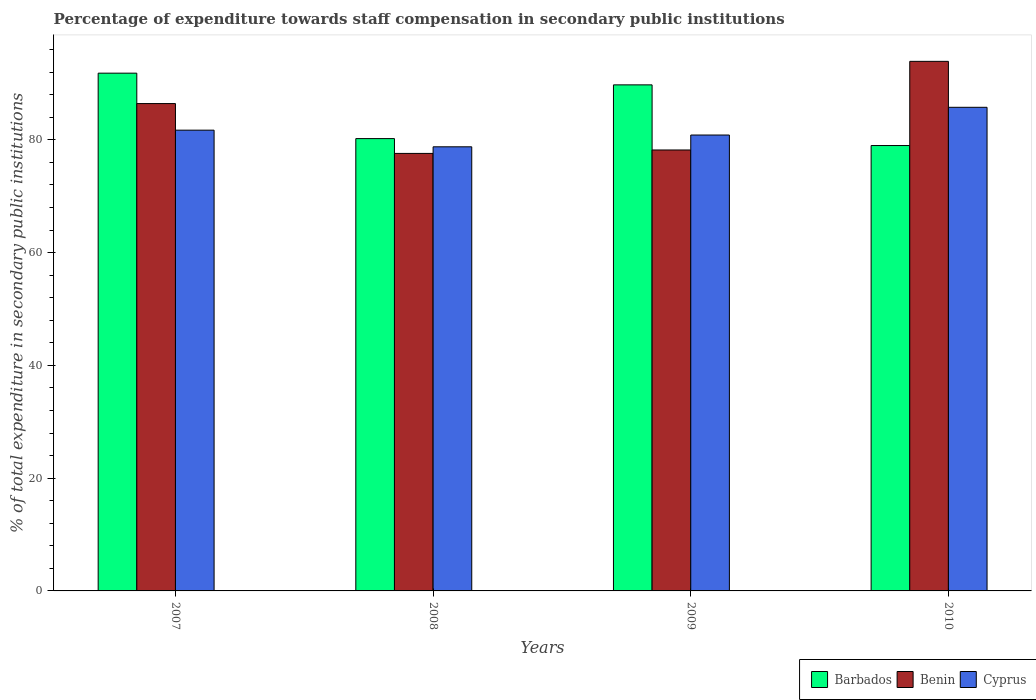How many groups of bars are there?
Ensure brevity in your answer.  4. How many bars are there on the 3rd tick from the left?
Provide a short and direct response. 3. What is the label of the 3rd group of bars from the left?
Give a very brief answer. 2009. In how many cases, is the number of bars for a given year not equal to the number of legend labels?
Your response must be concise. 0. What is the percentage of expenditure towards staff compensation in Cyprus in 2007?
Give a very brief answer. 81.71. Across all years, what is the maximum percentage of expenditure towards staff compensation in Barbados?
Give a very brief answer. 91.82. Across all years, what is the minimum percentage of expenditure towards staff compensation in Benin?
Ensure brevity in your answer.  77.59. In which year was the percentage of expenditure towards staff compensation in Barbados maximum?
Ensure brevity in your answer.  2007. In which year was the percentage of expenditure towards staff compensation in Cyprus minimum?
Your response must be concise. 2008. What is the total percentage of expenditure towards staff compensation in Barbados in the graph?
Offer a very short reply. 340.76. What is the difference between the percentage of expenditure towards staff compensation in Barbados in 2008 and that in 2009?
Your answer should be compact. -9.53. What is the difference between the percentage of expenditure towards staff compensation in Benin in 2008 and the percentage of expenditure towards staff compensation in Barbados in 2009?
Your response must be concise. -12.15. What is the average percentage of expenditure towards staff compensation in Benin per year?
Your answer should be very brief. 84.03. In the year 2010, what is the difference between the percentage of expenditure towards staff compensation in Cyprus and percentage of expenditure towards staff compensation in Benin?
Provide a short and direct response. -8.15. In how many years, is the percentage of expenditure towards staff compensation in Benin greater than 36 %?
Your answer should be compact. 4. What is the ratio of the percentage of expenditure towards staff compensation in Benin in 2008 to that in 2009?
Keep it short and to the point. 0.99. What is the difference between the highest and the second highest percentage of expenditure towards staff compensation in Cyprus?
Your answer should be very brief. 4.05. What is the difference between the highest and the lowest percentage of expenditure towards staff compensation in Cyprus?
Provide a succinct answer. 7. What does the 2nd bar from the left in 2008 represents?
Your response must be concise. Benin. What does the 1st bar from the right in 2010 represents?
Your response must be concise. Cyprus. Is it the case that in every year, the sum of the percentage of expenditure towards staff compensation in Benin and percentage of expenditure towards staff compensation in Cyprus is greater than the percentage of expenditure towards staff compensation in Barbados?
Your response must be concise. Yes. How many years are there in the graph?
Your answer should be compact. 4. Are the values on the major ticks of Y-axis written in scientific E-notation?
Give a very brief answer. No. Does the graph contain grids?
Provide a succinct answer. No. Where does the legend appear in the graph?
Give a very brief answer. Bottom right. How many legend labels are there?
Keep it short and to the point. 3. How are the legend labels stacked?
Keep it short and to the point. Horizontal. What is the title of the graph?
Offer a very short reply. Percentage of expenditure towards staff compensation in secondary public institutions. Does "Nepal" appear as one of the legend labels in the graph?
Make the answer very short. No. What is the label or title of the X-axis?
Ensure brevity in your answer.  Years. What is the label or title of the Y-axis?
Make the answer very short. % of total expenditure in secondary public institutions. What is the % of total expenditure in secondary public institutions in Barbados in 2007?
Ensure brevity in your answer.  91.82. What is the % of total expenditure in secondary public institutions in Benin in 2007?
Make the answer very short. 86.43. What is the % of total expenditure in secondary public institutions in Cyprus in 2007?
Your response must be concise. 81.71. What is the % of total expenditure in secondary public institutions of Barbados in 2008?
Ensure brevity in your answer.  80.22. What is the % of total expenditure in secondary public institutions in Benin in 2008?
Your answer should be compact. 77.59. What is the % of total expenditure in secondary public institutions in Cyprus in 2008?
Keep it short and to the point. 78.76. What is the % of total expenditure in secondary public institutions of Barbados in 2009?
Make the answer very short. 89.74. What is the % of total expenditure in secondary public institutions in Benin in 2009?
Offer a very short reply. 78.2. What is the % of total expenditure in secondary public institutions of Cyprus in 2009?
Keep it short and to the point. 80.85. What is the % of total expenditure in secondary public institutions in Barbados in 2010?
Ensure brevity in your answer.  78.98. What is the % of total expenditure in secondary public institutions of Benin in 2010?
Make the answer very short. 93.91. What is the % of total expenditure in secondary public institutions of Cyprus in 2010?
Offer a terse response. 85.76. Across all years, what is the maximum % of total expenditure in secondary public institutions in Barbados?
Your answer should be very brief. 91.82. Across all years, what is the maximum % of total expenditure in secondary public institutions of Benin?
Make the answer very short. 93.91. Across all years, what is the maximum % of total expenditure in secondary public institutions of Cyprus?
Give a very brief answer. 85.76. Across all years, what is the minimum % of total expenditure in secondary public institutions of Barbados?
Offer a very short reply. 78.98. Across all years, what is the minimum % of total expenditure in secondary public institutions of Benin?
Provide a succinct answer. 77.59. Across all years, what is the minimum % of total expenditure in secondary public institutions of Cyprus?
Keep it short and to the point. 78.76. What is the total % of total expenditure in secondary public institutions of Barbados in the graph?
Offer a terse response. 340.76. What is the total % of total expenditure in secondary public institutions of Benin in the graph?
Your response must be concise. 336.13. What is the total % of total expenditure in secondary public institutions of Cyprus in the graph?
Make the answer very short. 327.09. What is the difference between the % of total expenditure in secondary public institutions of Barbados in 2007 and that in 2008?
Keep it short and to the point. 11.61. What is the difference between the % of total expenditure in secondary public institutions in Benin in 2007 and that in 2008?
Your answer should be very brief. 8.84. What is the difference between the % of total expenditure in secondary public institutions of Cyprus in 2007 and that in 2008?
Your response must be concise. 2.95. What is the difference between the % of total expenditure in secondary public institutions of Barbados in 2007 and that in 2009?
Provide a succinct answer. 2.08. What is the difference between the % of total expenditure in secondary public institutions in Benin in 2007 and that in 2009?
Give a very brief answer. 8.23. What is the difference between the % of total expenditure in secondary public institutions in Cyprus in 2007 and that in 2009?
Your answer should be very brief. 0.86. What is the difference between the % of total expenditure in secondary public institutions in Barbados in 2007 and that in 2010?
Provide a succinct answer. 12.84. What is the difference between the % of total expenditure in secondary public institutions of Benin in 2007 and that in 2010?
Provide a short and direct response. -7.49. What is the difference between the % of total expenditure in secondary public institutions of Cyprus in 2007 and that in 2010?
Offer a very short reply. -4.05. What is the difference between the % of total expenditure in secondary public institutions in Barbados in 2008 and that in 2009?
Offer a terse response. -9.53. What is the difference between the % of total expenditure in secondary public institutions in Benin in 2008 and that in 2009?
Provide a succinct answer. -0.61. What is the difference between the % of total expenditure in secondary public institutions of Cyprus in 2008 and that in 2009?
Make the answer very short. -2.09. What is the difference between the % of total expenditure in secondary public institutions in Barbados in 2008 and that in 2010?
Provide a succinct answer. 1.23. What is the difference between the % of total expenditure in secondary public institutions of Benin in 2008 and that in 2010?
Your answer should be very brief. -16.33. What is the difference between the % of total expenditure in secondary public institutions of Cyprus in 2008 and that in 2010?
Ensure brevity in your answer.  -7. What is the difference between the % of total expenditure in secondary public institutions in Barbados in 2009 and that in 2010?
Your answer should be compact. 10.76. What is the difference between the % of total expenditure in secondary public institutions in Benin in 2009 and that in 2010?
Give a very brief answer. -15.72. What is the difference between the % of total expenditure in secondary public institutions of Cyprus in 2009 and that in 2010?
Your answer should be compact. -4.91. What is the difference between the % of total expenditure in secondary public institutions in Barbados in 2007 and the % of total expenditure in secondary public institutions in Benin in 2008?
Your answer should be compact. 14.23. What is the difference between the % of total expenditure in secondary public institutions in Barbados in 2007 and the % of total expenditure in secondary public institutions in Cyprus in 2008?
Ensure brevity in your answer.  13.06. What is the difference between the % of total expenditure in secondary public institutions in Benin in 2007 and the % of total expenditure in secondary public institutions in Cyprus in 2008?
Your answer should be very brief. 7.67. What is the difference between the % of total expenditure in secondary public institutions of Barbados in 2007 and the % of total expenditure in secondary public institutions of Benin in 2009?
Make the answer very short. 13.62. What is the difference between the % of total expenditure in secondary public institutions of Barbados in 2007 and the % of total expenditure in secondary public institutions of Cyprus in 2009?
Your answer should be compact. 10.97. What is the difference between the % of total expenditure in secondary public institutions of Benin in 2007 and the % of total expenditure in secondary public institutions of Cyprus in 2009?
Ensure brevity in your answer.  5.58. What is the difference between the % of total expenditure in secondary public institutions of Barbados in 2007 and the % of total expenditure in secondary public institutions of Benin in 2010?
Provide a short and direct response. -2.09. What is the difference between the % of total expenditure in secondary public institutions in Barbados in 2007 and the % of total expenditure in secondary public institutions in Cyprus in 2010?
Your answer should be very brief. 6.06. What is the difference between the % of total expenditure in secondary public institutions of Benin in 2007 and the % of total expenditure in secondary public institutions of Cyprus in 2010?
Offer a terse response. 0.66. What is the difference between the % of total expenditure in secondary public institutions in Barbados in 2008 and the % of total expenditure in secondary public institutions in Benin in 2009?
Your response must be concise. 2.02. What is the difference between the % of total expenditure in secondary public institutions of Barbados in 2008 and the % of total expenditure in secondary public institutions of Cyprus in 2009?
Keep it short and to the point. -0.64. What is the difference between the % of total expenditure in secondary public institutions of Benin in 2008 and the % of total expenditure in secondary public institutions of Cyprus in 2009?
Keep it short and to the point. -3.26. What is the difference between the % of total expenditure in secondary public institutions in Barbados in 2008 and the % of total expenditure in secondary public institutions in Benin in 2010?
Make the answer very short. -13.7. What is the difference between the % of total expenditure in secondary public institutions of Barbados in 2008 and the % of total expenditure in secondary public institutions of Cyprus in 2010?
Your response must be concise. -5.55. What is the difference between the % of total expenditure in secondary public institutions in Benin in 2008 and the % of total expenditure in secondary public institutions in Cyprus in 2010?
Your answer should be very brief. -8.17. What is the difference between the % of total expenditure in secondary public institutions of Barbados in 2009 and the % of total expenditure in secondary public institutions of Benin in 2010?
Give a very brief answer. -4.17. What is the difference between the % of total expenditure in secondary public institutions in Barbados in 2009 and the % of total expenditure in secondary public institutions in Cyprus in 2010?
Your answer should be compact. 3.98. What is the difference between the % of total expenditure in secondary public institutions in Benin in 2009 and the % of total expenditure in secondary public institutions in Cyprus in 2010?
Keep it short and to the point. -7.57. What is the average % of total expenditure in secondary public institutions of Barbados per year?
Provide a succinct answer. 85.19. What is the average % of total expenditure in secondary public institutions of Benin per year?
Offer a very short reply. 84.03. What is the average % of total expenditure in secondary public institutions of Cyprus per year?
Your response must be concise. 81.77. In the year 2007, what is the difference between the % of total expenditure in secondary public institutions in Barbados and % of total expenditure in secondary public institutions in Benin?
Provide a succinct answer. 5.39. In the year 2007, what is the difference between the % of total expenditure in secondary public institutions of Barbados and % of total expenditure in secondary public institutions of Cyprus?
Provide a short and direct response. 10.11. In the year 2007, what is the difference between the % of total expenditure in secondary public institutions in Benin and % of total expenditure in secondary public institutions in Cyprus?
Your answer should be very brief. 4.71. In the year 2008, what is the difference between the % of total expenditure in secondary public institutions of Barbados and % of total expenditure in secondary public institutions of Benin?
Your response must be concise. 2.63. In the year 2008, what is the difference between the % of total expenditure in secondary public institutions in Barbados and % of total expenditure in secondary public institutions in Cyprus?
Make the answer very short. 1.45. In the year 2008, what is the difference between the % of total expenditure in secondary public institutions in Benin and % of total expenditure in secondary public institutions in Cyprus?
Provide a short and direct response. -1.17. In the year 2009, what is the difference between the % of total expenditure in secondary public institutions in Barbados and % of total expenditure in secondary public institutions in Benin?
Your answer should be very brief. 11.55. In the year 2009, what is the difference between the % of total expenditure in secondary public institutions of Barbados and % of total expenditure in secondary public institutions of Cyprus?
Ensure brevity in your answer.  8.89. In the year 2009, what is the difference between the % of total expenditure in secondary public institutions of Benin and % of total expenditure in secondary public institutions of Cyprus?
Make the answer very short. -2.65. In the year 2010, what is the difference between the % of total expenditure in secondary public institutions of Barbados and % of total expenditure in secondary public institutions of Benin?
Your response must be concise. -14.93. In the year 2010, what is the difference between the % of total expenditure in secondary public institutions in Barbados and % of total expenditure in secondary public institutions in Cyprus?
Keep it short and to the point. -6.78. In the year 2010, what is the difference between the % of total expenditure in secondary public institutions in Benin and % of total expenditure in secondary public institutions in Cyprus?
Offer a very short reply. 8.15. What is the ratio of the % of total expenditure in secondary public institutions in Barbados in 2007 to that in 2008?
Offer a very short reply. 1.14. What is the ratio of the % of total expenditure in secondary public institutions in Benin in 2007 to that in 2008?
Ensure brevity in your answer.  1.11. What is the ratio of the % of total expenditure in secondary public institutions of Cyprus in 2007 to that in 2008?
Provide a short and direct response. 1.04. What is the ratio of the % of total expenditure in secondary public institutions of Barbados in 2007 to that in 2009?
Provide a short and direct response. 1.02. What is the ratio of the % of total expenditure in secondary public institutions in Benin in 2007 to that in 2009?
Your answer should be very brief. 1.11. What is the ratio of the % of total expenditure in secondary public institutions of Cyprus in 2007 to that in 2009?
Your answer should be very brief. 1.01. What is the ratio of the % of total expenditure in secondary public institutions in Barbados in 2007 to that in 2010?
Your answer should be very brief. 1.16. What is the ratio of the % of total expenditure in secondary public institutions of Benin in 2007 to that in 2010?
Give a very brief answer. 0.92. What is the ratio of the % of total expenditure in secondary public institutions of Cyprus in 2007 to that in 2010?
Provide a short and direct response. 0.95. What is the ratio of the % of total expenditure in secondary public institutions of Barbados in 2008 to that in 2009?
Make the answer very short. 0.89. What is the ratio of the % of total expenditure in secondary public institutions of Cyprus in 2008 to that in 2009?
Give a very brief answer. 0.97. What is the ratio of the % of total expenditure in secondary public institutions in Barbados in 2008 to that in 2010?
Make the answer very short. 1.02. What is the ratio of the % of total expenditure in secondary public institutions in Benin in 2008 to that in 2010?
Your answer should be very brief. 0.83. What is the ratio of the % of total expenditure in secondary public institutions of Cyprus in 2008 to that in 2010?
Make the answer very short. 0.92. What is the ratio of the % of total expenditure in secondary public institutions in Barbados in 2009 to that in 2010?
Your answer should be compact. 1.14. What is the ratio of the % of total expenditure in secondary public institutions of Benin in 2009 to that in 2010?
Offer a very short reply. 0.83. What is the ratio of the % of total expenditure in secondary public institutions in Cyprus in 2009 to that in 2010?
Ensure brevity in your answer.  0.94. What is the difference between the highest and the second highest % of total expenditure in secondary public institutions of Barbados?
Give a very brief answer. 2.08. What is the difference between the highest and the second highest % of total expenditure in secondary public institutions of Benin?
Provide a succinct answer. 7.49. What is the difference between the highest and the second highest % of total expenditure in secondary public institutions in Cyprus?
Give a very brief answer. 4.05. What is the difference between the highest and the lowest % of total expenditure in secondary public institutions in Barbados?
Keep it short and to the point. 12.84. What is the difference between the highest and the lowest % of total expenditure in secondary public institutions in Benin?
Make the answer very short. 16.33. What is the difference between the highest and the lowest % of total expenditure in secondary public institutions in Cyprus?
Your answer should be very brief. 7. 